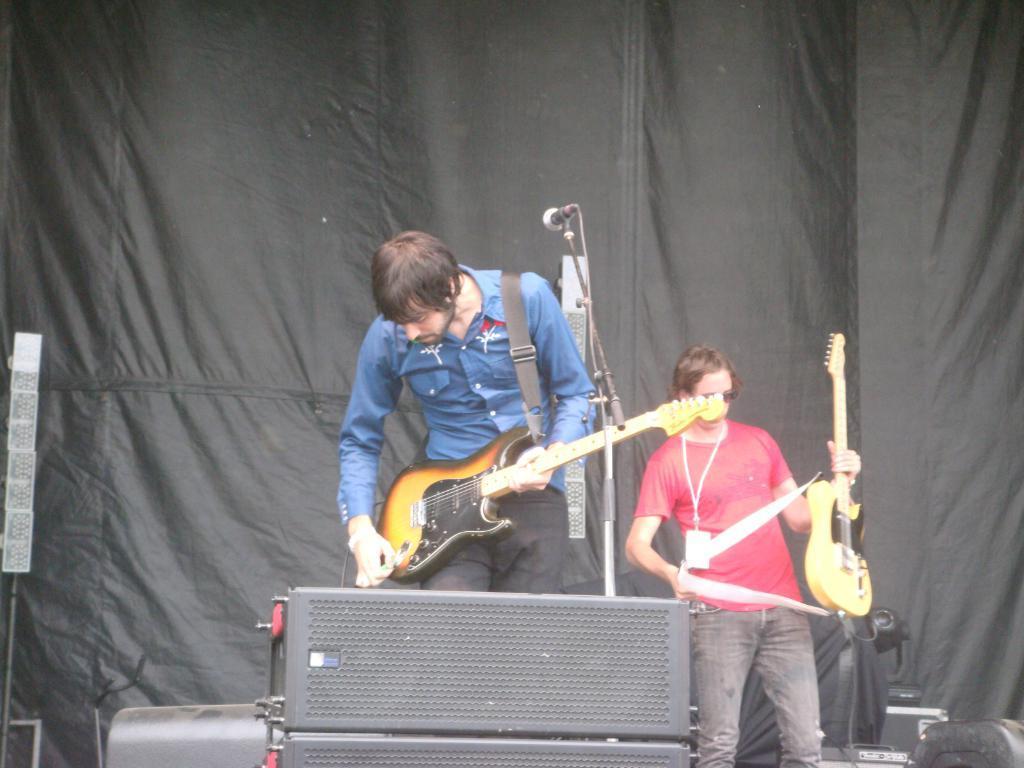How would you summarize this image in a sentence or two? This is a picture of a live performance. In the foreground there are speakers. In the center of the picture there is a man standing and playing guitar. There is a microphone in the center of the picture. In the background there is a man in red t-shirt holding guitar. In the background there is a black curtain. 